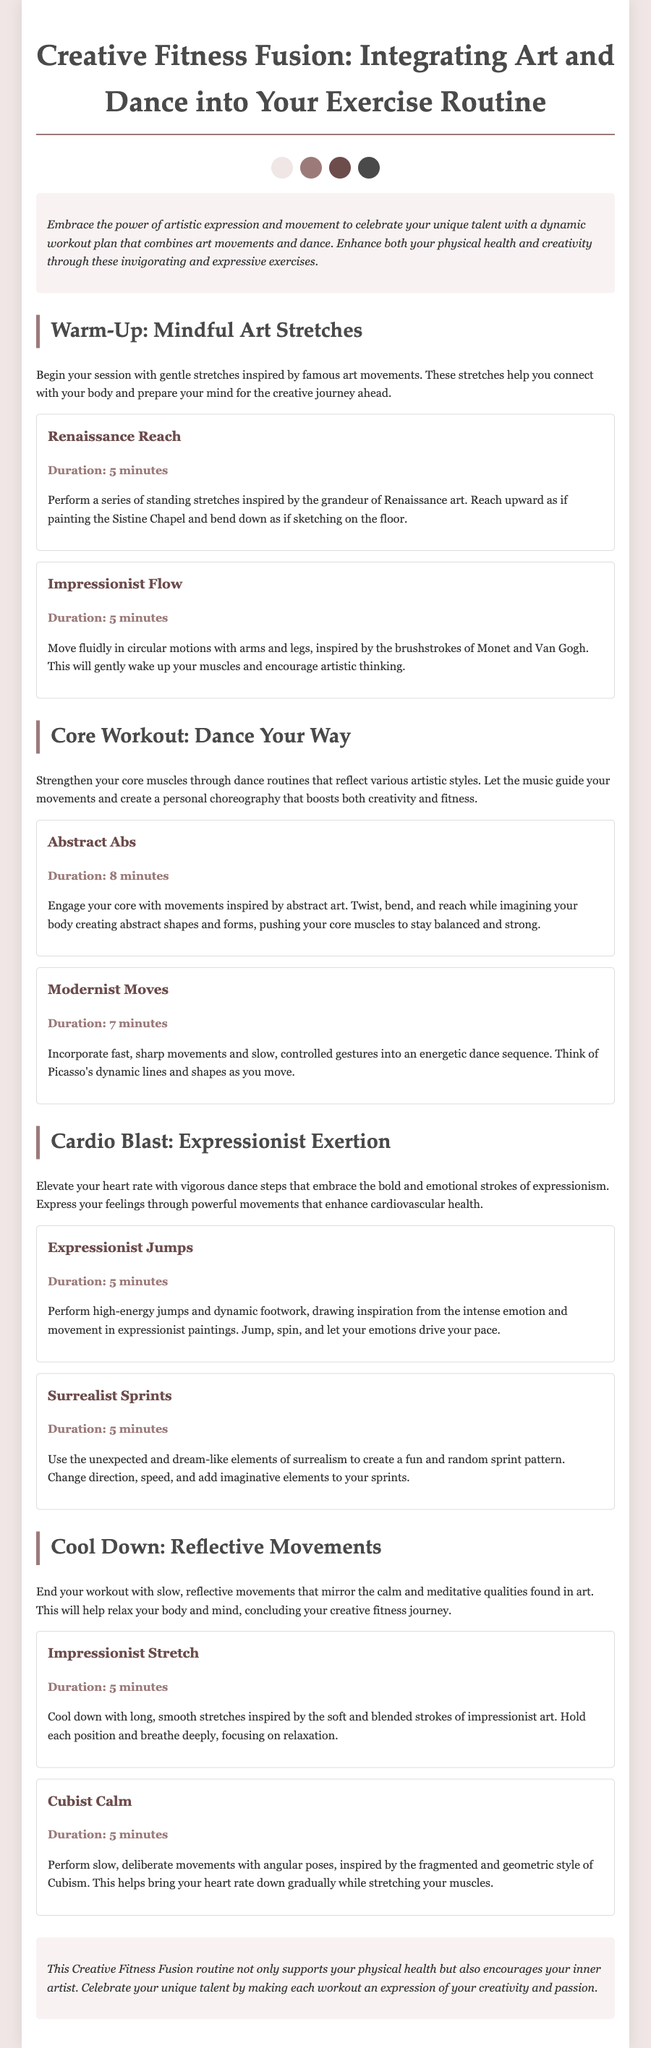What is the title of the workout plan? The title of the workout plan is the first heading in the document that introduces the concept.
Answer: Creative Fitness Fusion: Integrating Art and Dance into Your Exercise Routine How many warm-up activities are listed? The document provides a specific number of activities under the warm-up section.
Answer: 2 What is the duration of the "Abstract Abs" activity? The duration of "Abstract Abs" is explicitly mentioned under its description in the core workout section.
Answer: 8 minutes What artistic style inspires the "Renaissance Reach"? The activity description indicates the specific art movement that inspires the warm-up.
Answer: Renaissance Which section includes "Surrealist Sprints"? This question refers to the section where the specific cardio activity is categorized within the workout plan.
Answer: Cardio Blast: Expressionist Exertion What type of movements are performed during the cool-down? The cool-down section describes the nature of movements performed to conclude the workout.
Answer: Reflective Movements How many minutes are dedicated to the "Expressionist Jumps"? This information can be found in the activity description related to cardio workouts.
Answer: 5 minutes What is emphasized at the end of the workout plan? The conclusion summarizes the goal of the workout routine based on the document's contents.
Answer: Creative expression 